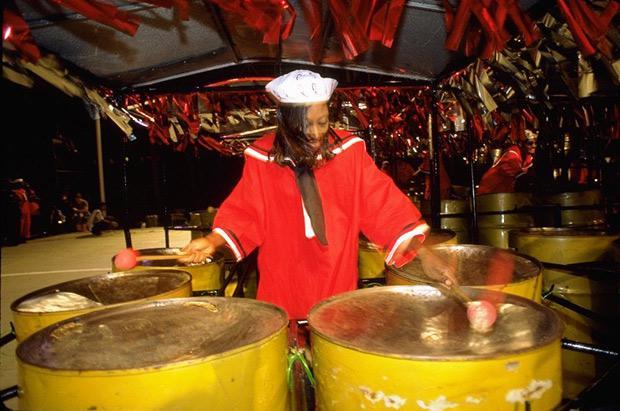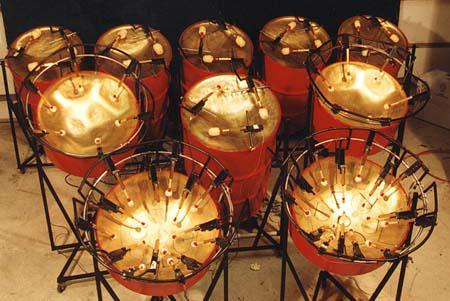The first image is the image on the left, the second image is the image on the right. For the images displayed, is the sentence "Exactly one person is playing steel drums." factually correct? Answer yes or no. Yes. The first image is the image on the left, the second image is the image on the right. Assess this claim about the two images: "The left image contains a row of three musicians in matching shirts, and at least one of them holds drumsticks and has a steel drum at his front.". Correct or not? Answer yes or no. No. 